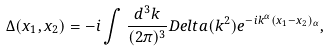Convert formula to latex. <formula><loc_0><loc_0><loc_500><loc_500>\Delta ( x _ { 1 } , x _ { 2 } ) = - i \int \frac { d ^ { 3 } k } { ( 2 \pi ) ^ { 3 } } D e l t a ( k ^ { 2 } ) e ^ { - i k ^ { \alpha } ( x _ { 1 } - x _ { 2 } ) _ { \alpha } } ,</formula> 